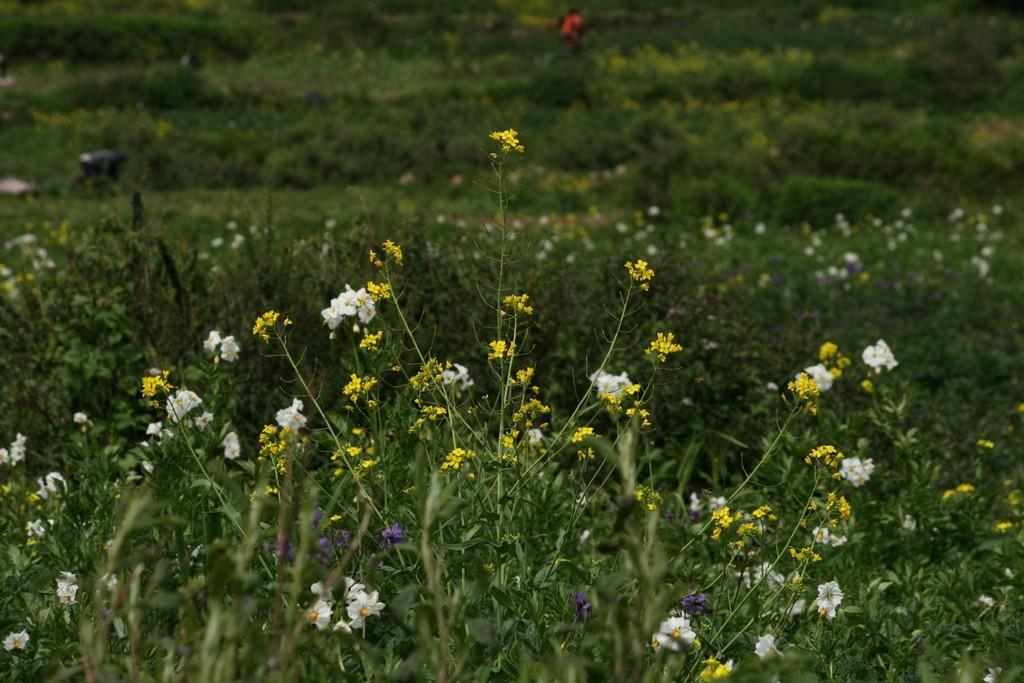What celestial bodies are shown in the image? There are planets depicted in the image. What unique feature do the planets have in the image? The planets have different color flowers. What type of bell can be seen ringing on one of the planets in the image? There is no bell present in the image; the planets have different color flowers. Is there a carriage visible on any of the planets in the image? There is no carriage present in the image; the planets have different color flowers. 